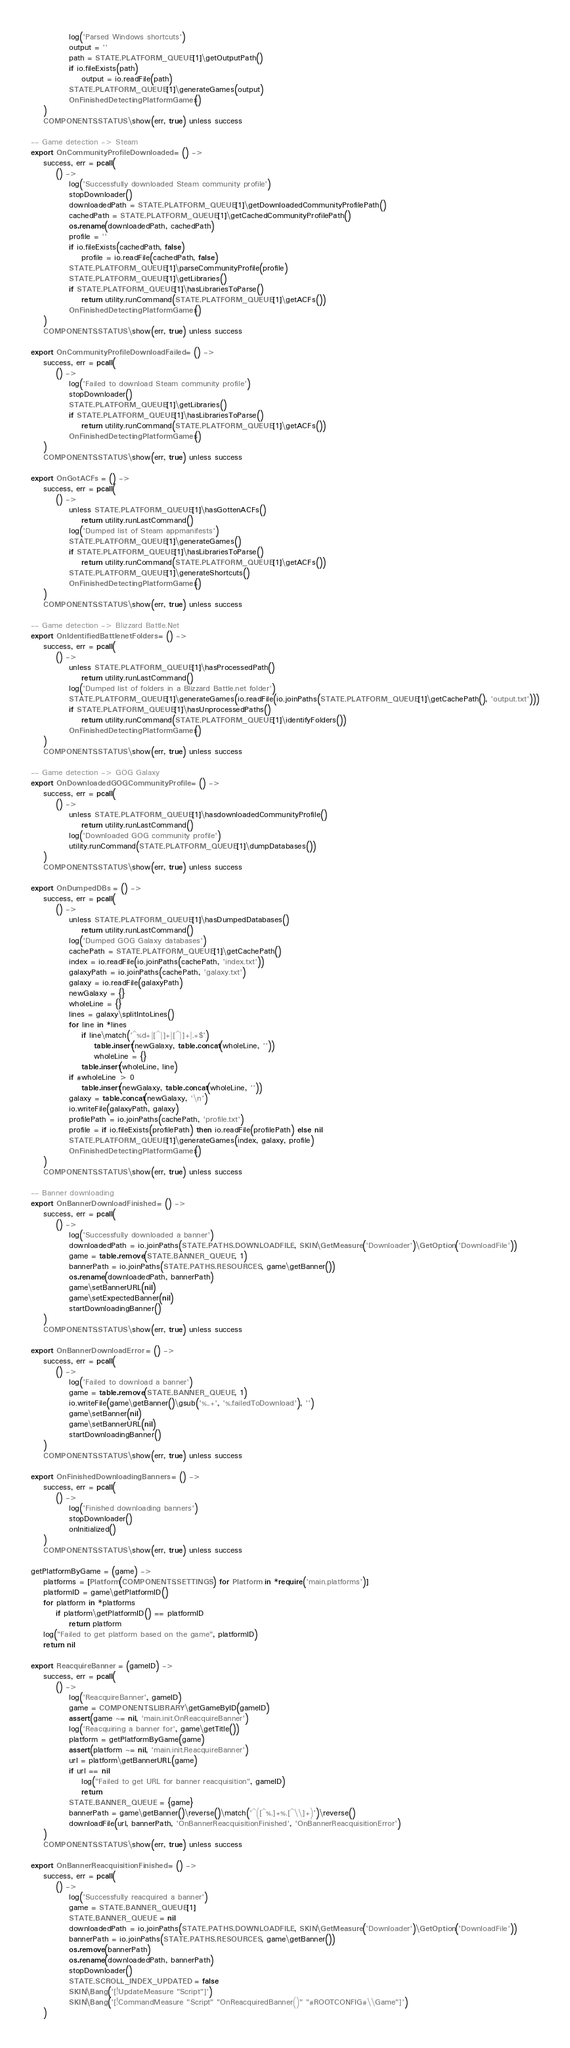<code> <loc_0><loc_0><loc_500><loc_500><_MoonScript_>			log('Parsed Windows shortcuts')
			output = ''
			path = STATE.PLATFORM_QUEUE[1]\getOutputPath()
			if io.fileExists(path)
				output = io.readFile(path)
			STATE.PLATFORM_QUEUE[1]\generateGames(output)
			OnFinishedDetectingPlatformGames()
	)
	COMPONENTS.STATUS\show(err, true) unless success

-- Game detection -> Steam
export OnCommunityProfileDownloaded = () ->
	success, err = pcall(
		() ->
			log('Successfully downloaded Steam community profile')
			stopDownloader()
			downloadedPath = STATE.PLATFORM_QUEUE[1]\getDownloadedCommunityProfilePath()
			cachedPath = STATE.PLATFORM_QUEUE[1]\getCachedCommunityProfilePath()
			os.rename(downloadedPath, cachedPath)
			profile = ''
			if io.fileExists(cachedPath, false)
				profile = io.readFile(cachedPath, false)
			STATE.PLATFORM_QUEUE[1]\parseCommunityProfile(profile)
			STATE.PLATFORM_QUEUE[1]\getLibraries()
			if STATE.PLATFORM_QUEUE[1]\hasLibrariesToParse()
				return utility.runCommand(STATE.PLATFORM_QUEUE[1]\getACFs())
			OnFinishedDetectingPlatformGames()
	)
	COMPONENTS.STATUS\show(err, true) unless success

export OnCommunityProfileDownloadFailed = () ->
	success, err = pcall(
		() ->
			log('Failed to download Steam community profile')
			stopDownloader()
			STATE.PLATFORM_QUEUE[1]\getLibraries()
			if STATE.PLATFORM_QUEUE[1]\hasLibrariesToParse()
				return utility.runCommand(STATE.PLATFORM_QUEUE[1]\getACFs())
			OnFinishedDetectingPlatformGames()
	)
	COMPONENTS.STATUS\show(err, true) unless success

export OnGotACFs = () ->
	success, err = pcall(
		() ->
			unless STATE.PLATFORM_QUEUE[1]\hasGottenACFs()
				return utility.runLastCommand()
			log('Dumped list of Steam appmanifests')
			STATE.PLATFORM_QUEUE[1]\generateGames()
			if STATE.PLATFORM_QUEUE[1]\hasLibrariesToParse()
				return utility.runCommand(STATE.PLATFORM_QUEUE[1]\getACFs())
			STATE.PLATFORM_QUEUE[1]\generateShortcuts()
			OnFinishedDetectingPlatformGames()
	)
	COMPONENTS.STATUS\show(err, true) unless success

-- Game detection -> Blizzard Battle.Net
export OnIdentifiedBattlenetFolders = () ->
	success, err = pcall(
		() ->
			unless STATE.PLATFORM_QUEUE[1]\hasProcessedPath()
				return utility.runLastCommand()
			log('Dumped list of folders in a Blizzard Battle.net folder')
			STATE.PLATFORM_QUEUE[1]\generateGames(io.readFile(io.joinPaths(STATE.PLATFORM_QUEUE[1]\getCachePath(), 'output.txt')))
			if STATE.PLATFORM_QUEUE[1]\hasUnprocessedPaths()
				return utility.runCommand(STATE.PLATFORM_QUEUE[1]\identifyFolders())
			OnFinishedDetectingPlatformGames()
	)
	COMPONENTS.STATUS\show(err, true) unless success

-- Game detection -> GOG Galaxy
export OnDownloadedGOGCommunityProfile = () ->
	success, err = pcall(
		() ->
			unless STATE.PLATFORM_QUEUE[1]\hasdownloadedCommunityProfile()
				return utility.runLastCommand()
			log('Downloaded GOG community profile')
			utility.runCommand(STATE.PLATFORM_QUEUE[1]\dumpDatabases())
	)
	COMPONENTS.STATUS\show(err, true) unless success

export OnDumpedDBs = () ->
	success, err = pcall(
		() ->
			unless STATE.PLATFORM_QUEUE[1]\hasDumpedDatabases()
				return utility.runLastCommand()
			log('Dumped GOG Galaxy databases')
			cachePath = STATE.PLATFORM_QUEUE[1]\getCachePath()
			index = io.readFile(io.joinPaths(cachePath, 'index.txt'))
			galaxyPath = io.joinPaths(cachePath, 'galaxy.txt')
			galaxy = io.readFile(galaxyPath)
			newGalaxy = {}
			wholeLine = {}
			lines = galaxy\splitIntoLines()
			for line in *lines
				if line\match('^%d+|[^|]+|[^|]+|.+$')
					table.insert(newGalaxy, table.concat(wholeLine, ''))
					wholeLine = {}
				table.insert(wholeLine, line)
			if #wholeLine > 0
				table.insert(newGalaxy, table.concat(wholeLine, ''))
			galaxy = table.concat(newGalaxy, '\n')
			io.writeFile(galaxyPath, galaxy)
			profilePath = io.joinPaths(cachePath, 'profile.txt')
			profile = if io.fileExists(profilePath) then io.readFile(profilePath) else nil
			STATE.PLATFORM_QUEUE[1]\generateGames(index, galaxy, profile)
			OnFinishedDetectingPlatformGames()
	)
	COMPONENTS.STATUS\show(err, true) unless success

-- Banner downloading
export OnBannerDownloadFinished = () ->
	success, err = pcall(
		() ->
			log('Successfully downloaded a banner')
			downloadedPath = io.joinPaths(STATE.PATHS.DOWNLOADFILE, SKIN\GetMeasure('Downloader')\GetOption('DownloadFile'))
			game = table.remove(STATE.BANNER_QUEUE, 1)
			bannerPath = io.joinPaths(STATE.PATHS.RESOURCES, game\getBanner())
			os.rename(downloadedPath, bannerPath)
			game\setBannerURL(nil)
			game\setExpectedBanner(nil)
			startDownloadingBanner()
	)
	COMPONENTS.STATUS\show(err, true) unless success

export OnBannerDownloadError = () ->
	success, err = pcall(
		() ->
			log('Failed to download a banner')
			game = table.remove(STATE.BANNER_QUEUE, 1)
			io.writeFile(game\getBanner()\gsub('%..+', '%.failedToDownload'), '')
			game\setBanner(nil)
			game\setBannerURL(nil)
			startDownloadingBanner()
	)
	COMPONENTS.STATUS\show(err, true) unless success

export OnFinishedDownloadingBanners = () ->
	success, err = pcall(
		() ->
			log('Finished downloading banners')
			stopDownloader()
			onInitialized()
	)
	COMPONENTS.STATUS\show(err, true) unless success

getPlatformByGame = (game) ->
	platforms = [Platform(COMPONENTS.SETTINGS) for Platform in *require('main.platforms')]
	platformID = game\getPlatformID()
	for platform in *platforms
		if platform\getPlatformID() == platformID
			return platform
	log("Failed to get platform based on the game", platformID)
	return nil

export ReacquireBanner = (gameID) ->
	success, err = pcall(
		() ->
			log('ReacquireBanner', gameID)
			game = COMPONENTS.LIBRARY\getGameByID(gameID)
			assert(game ~= nil, 'main.init.OnReacquireBanner')
			log('Reacquiring a banner for', game\getTitle())
			platform = getPlatformByGame(game)
			assert(platform ~= nil, 'main.init.ReacquireBanner')
			url = platform\getBannerURL(game)
			if url == nil
				log("Failed to get URL for banner reacquisition", gameID)
				return
			STATE.BANNER_QUEUE = {game}
			bannerPath = game\getBanner()\reverse()\match('^([^%.]+%.[^\\]+)')\reverse()
			downloadFile(url, bannerPath, 'OnBannerReacquisitionFinished', 'OnBannerReacquisitionError')
	)
	COMPONENTS.STATUS\show(err, true) unless success

export OnBannerReacquisitionFinished = () ->
	success, err = pcall(
		() ->
			log('Successfully reacquired a banner')
			game = STATE.BANNER_QUEUE[1]
			STATE.BANNER_QUEUE = nil
			downloadedPath = io.joinPaths(STATE.PATHS.DOWNLOADFILE, SKIN\GetMeasure('Downloader')\GetOption('DownloadFile'))
			bannerPath = io.joinPaths(STATE.PATHS.RESOURCES, game\getBanner())
			os.remove(bannerPath)
			os.rename(downloadedPath, bannerPath)
			stopDownloader()
			STATE.SCROLL_INDEX_UPDATED = false
			SKIN\Bang('[!UpdateMeasure "Script"]')
			SKIN\Bang('[!CommandMeasure "Script" "OnReacquiredBanner()" "#ROOTCONFIG#\\Game"]')
	)</code> 